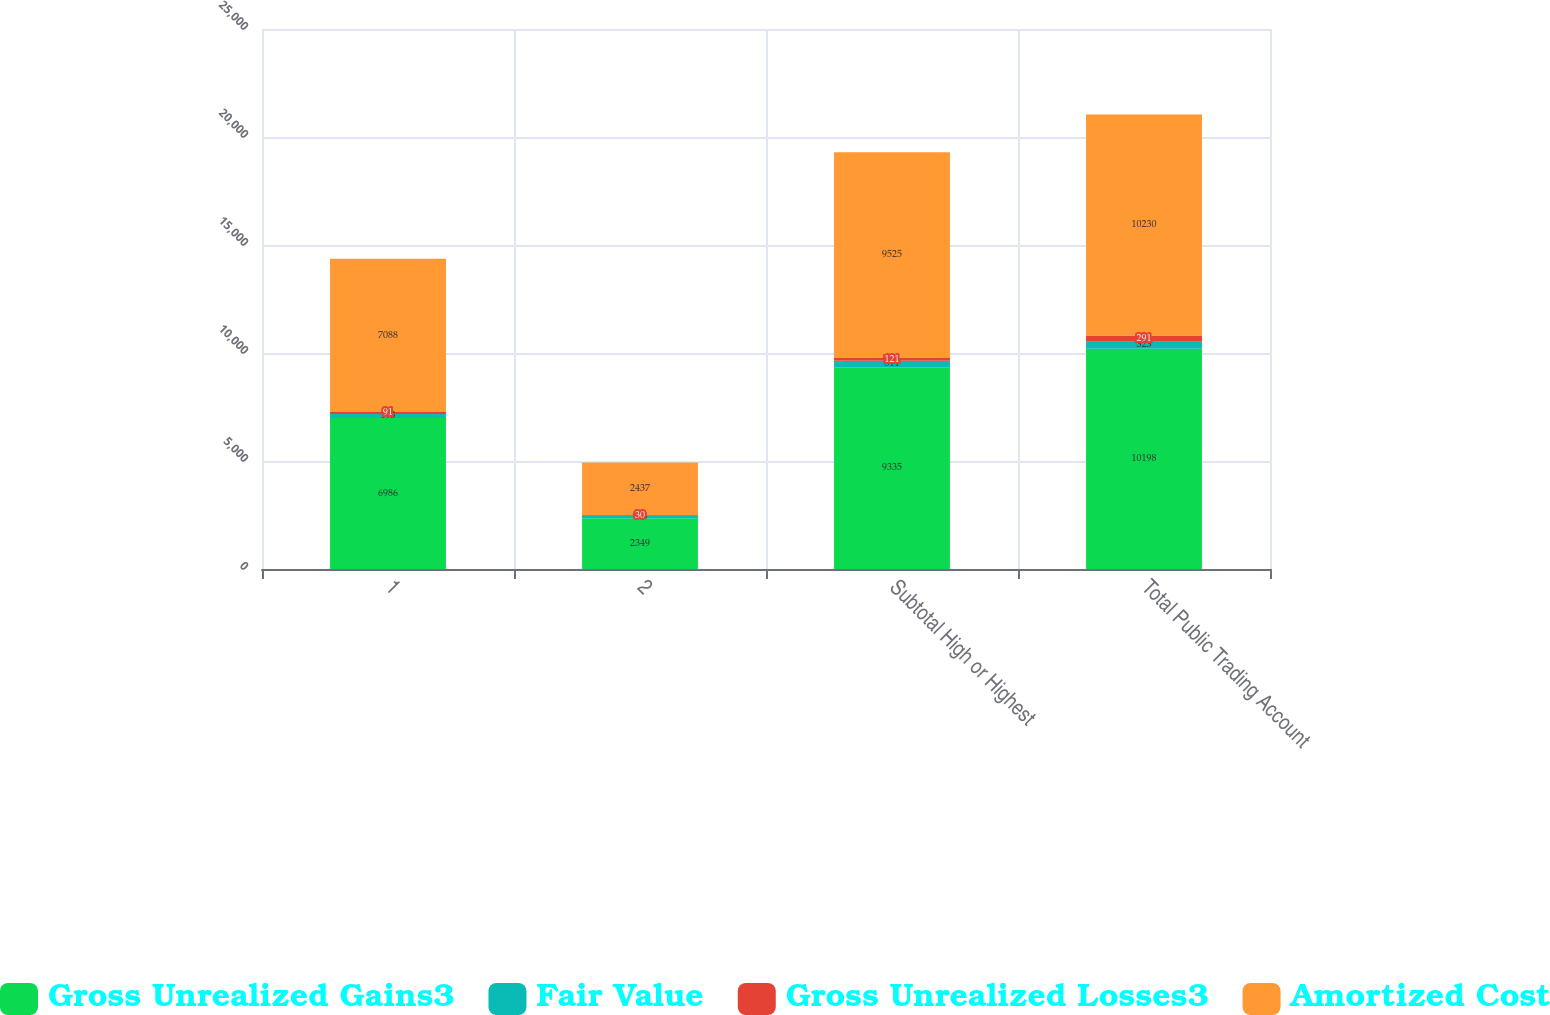Convert chart. <chart><loc_0><loc_0><loc_500><loc_500><stacked_bar_chart><ecel><fcel>1<fcel>2<fcel>Subtotal High or Highest<fcel>Total Public Trading Account<nl><fcel>Gross Unrealized Gains3<fcel>6986<fcel>2349<fcel>9335<fcel>10198<nl><fcel>Fair Value<fcel>193<fcel>118<fcel>311<fcel>323<nl><fcel>Gross Unrealized Losses3<fcel>91<fcel>30<fcel>121<fcel>291<nl><fcel>Amortized Cost<fcel>7088<fcel>2437<fcel>9525<fcel>10230<nl></chart> 